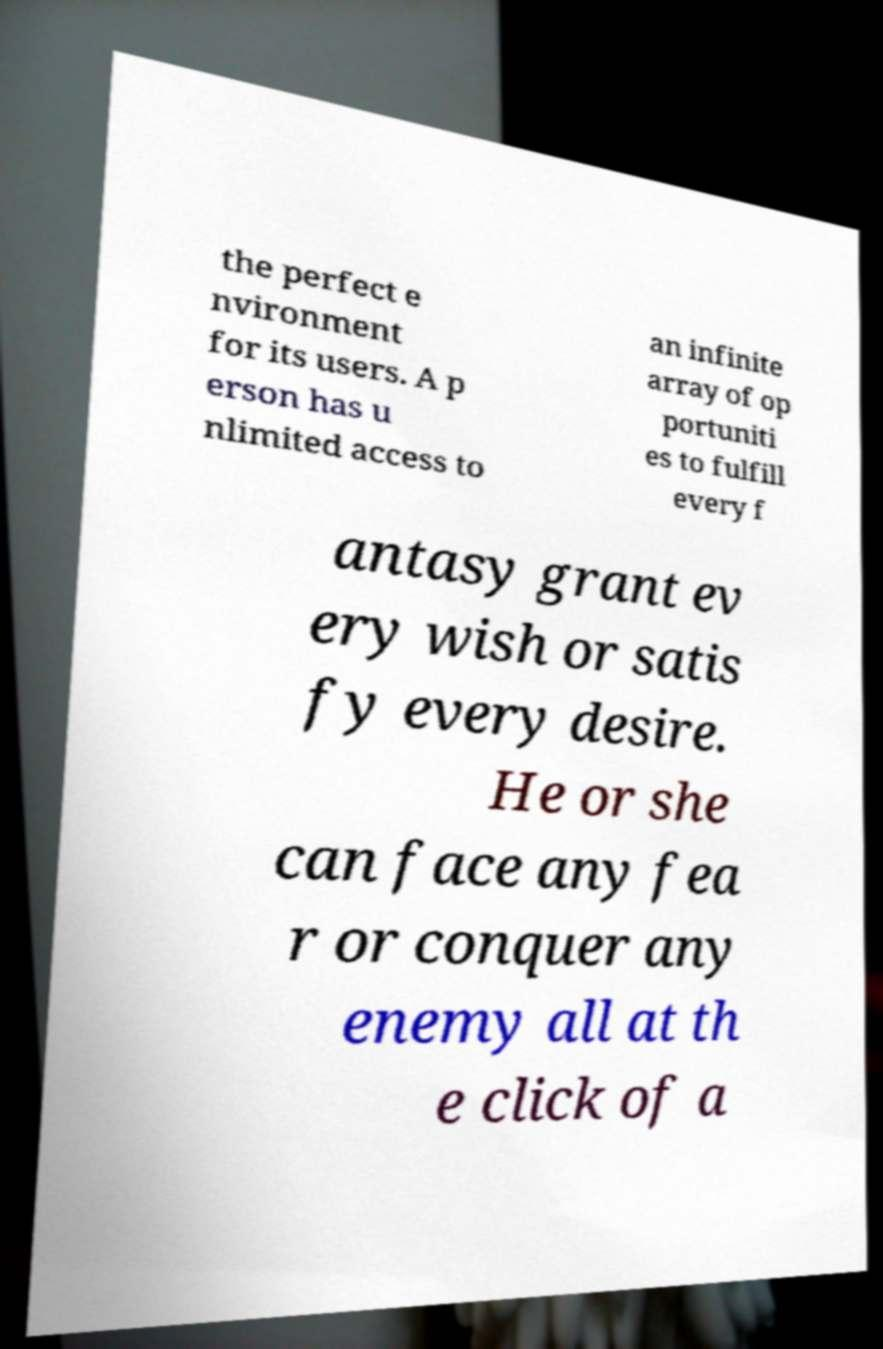There's text embedded in this image that I need extracted. Can you transcribe it verbatim? the perfect e nvironment for its users. A p erson has u nlimited access to an infinite array of op portuniti es to fulfill every f antasy grant ev ery wish or satis fy every desire. He or she can face any fea r or conquer any enemy all at th e click of a 